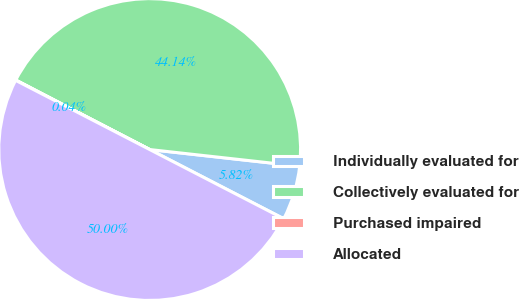Convert chart to OTSL. <chart><loc_0><loc_0><loc_500><loc_500><pie_chart><fcel>Individually evaluated for<fcel>Collectively evaluated for<fcel>Purchased impaired<fcel>Allocated<nl><fcel>5.82%<fcel>44.14%<fcel>0.04%<fcel>50.0%<nl></chart> 